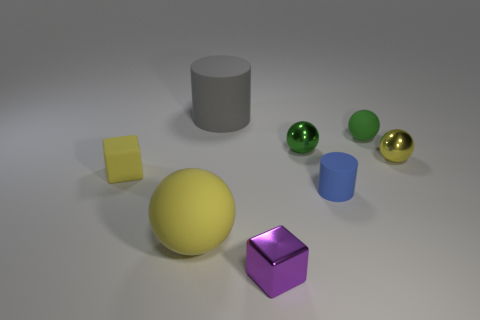Subtract all small rubber spheres. How many spheres are left? 3 Subtract all red balls. Subtract all purple cubes. How many balls are left? 4 Add 2 big gray rubber cylinders. How many objects exist? 10 Subtract all cylinders. How many objects are left? 6 Add 3 yellow metal spheres. How many yellow metal spheres are left? 4 Add 6 big blue cubes. How many big blue cubes exist? 6 Subtract 1 gray cylinders. How many objects are left? 7 Subtract all yellow rubber balls. Subtract all big rubber spheres. How many objects are left? 6 